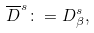Convert formula to latex. <formula><loc_0><loc_0><loc_500><loc_500>\overline { D } ^ { s } \colon = D _ { \beta } ^ { s } ,</formula> 